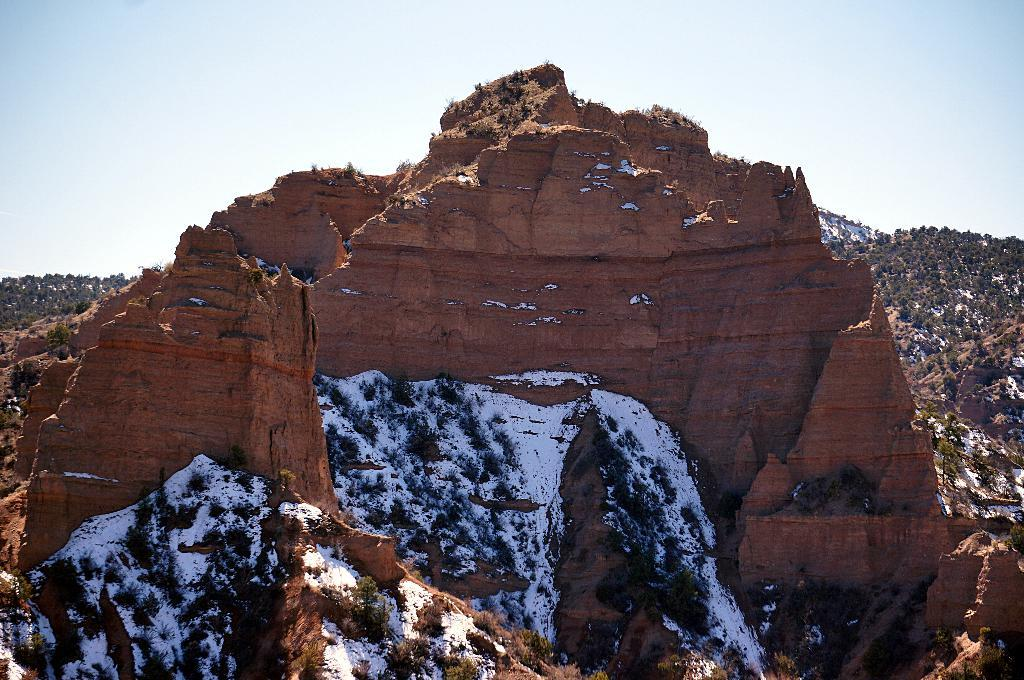What type of natural formation can be seen in the image? There are mountains in the image. What is covering the mountains in the image? There is snow on the mountain. What type of vegetation can be seen on the mountain? There are plants and trees on the mountain. What is visible in the background of the image? The sky is visible in the background of the image. What type of apparel are the children wearing in the image? There are no children present in the image; it features mountains with snow, plants, trees, and a visible sky. 